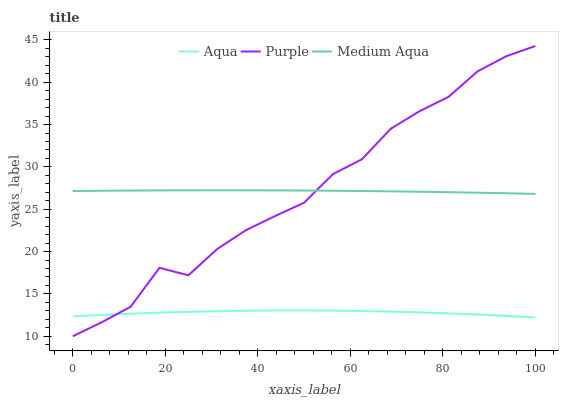Does Aqua have the minimum area under the curve?
Answer yes or no. Yes. Does Purple have the maximum area under the curve?
Answer yes or no. Yes. Does Medium Aqua have the minimum area under the curve?
Answer yes or no. No. Does Medium Aqua have the maximum area under the curve?
Answer yes or no. No. Is Medium Aqua the smoothest?
Answer yes or no. Yes. Is Purple the roughest?
Answer yes or no. Yes. Is Aqua the smoothest?
Answer yes or no. No. Is Aqua the roughest?
Answer yes or no. No. Does Purple have the lowest value?
Answer yes or no. Yes. Does Aqua have the lowest value?
Answer yes or no. No. Does Purple have the highest value?
Answer yes or no. Yes. Does Medium Aqua have the highest value?
Answer yes or no. No. Is Aqua less than Medium Aqua?
Answer yes or no. Yes. Is Medium Aqua greater than Aqua?
Answer yes or no. Yes. Does Medium Aqua intersect Purple?
Answer yes or no. Yes. Is Medium Aqua less than Purple?
Answer yes or no. No. Is Medium Aqua greater than Purple?
Answer yes or no. No. Does Aqua intersect Medium Aqua?
Answer yes or no. No. 